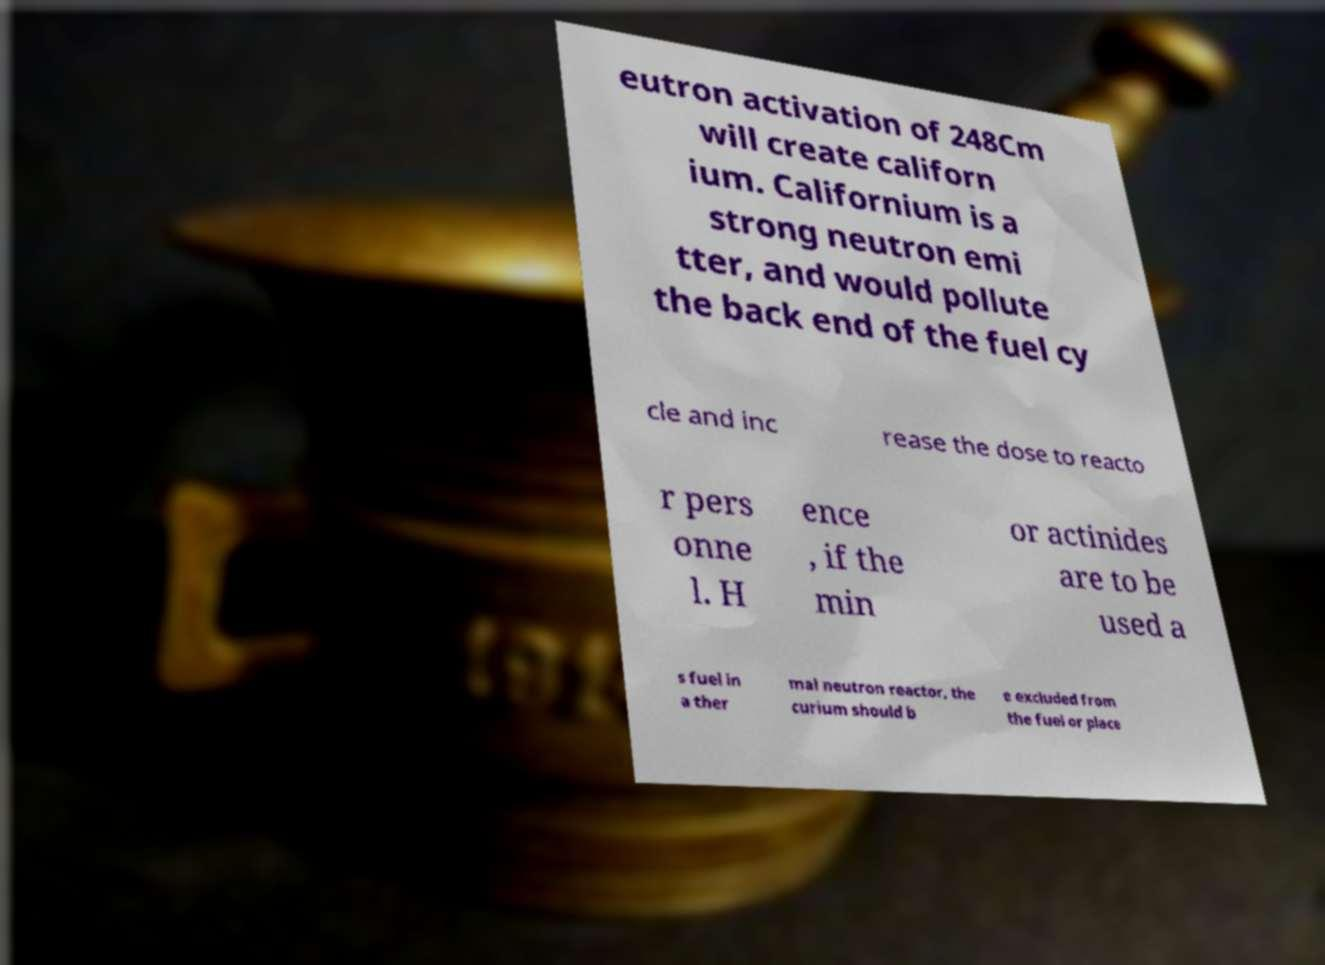Please read and relay the text visible in this image. What does it say? eutron activation of 248Cm will create californ ium. Californium is a strong neutron emi tter, and would pollute the back end of the fuel cy cle and inc rease the dose to reacto r pers onne l. H ence , if the min or actinides are to be used a s fuel in a ther mal neutron reactor, the curium should b e excluded from the fuel or place 